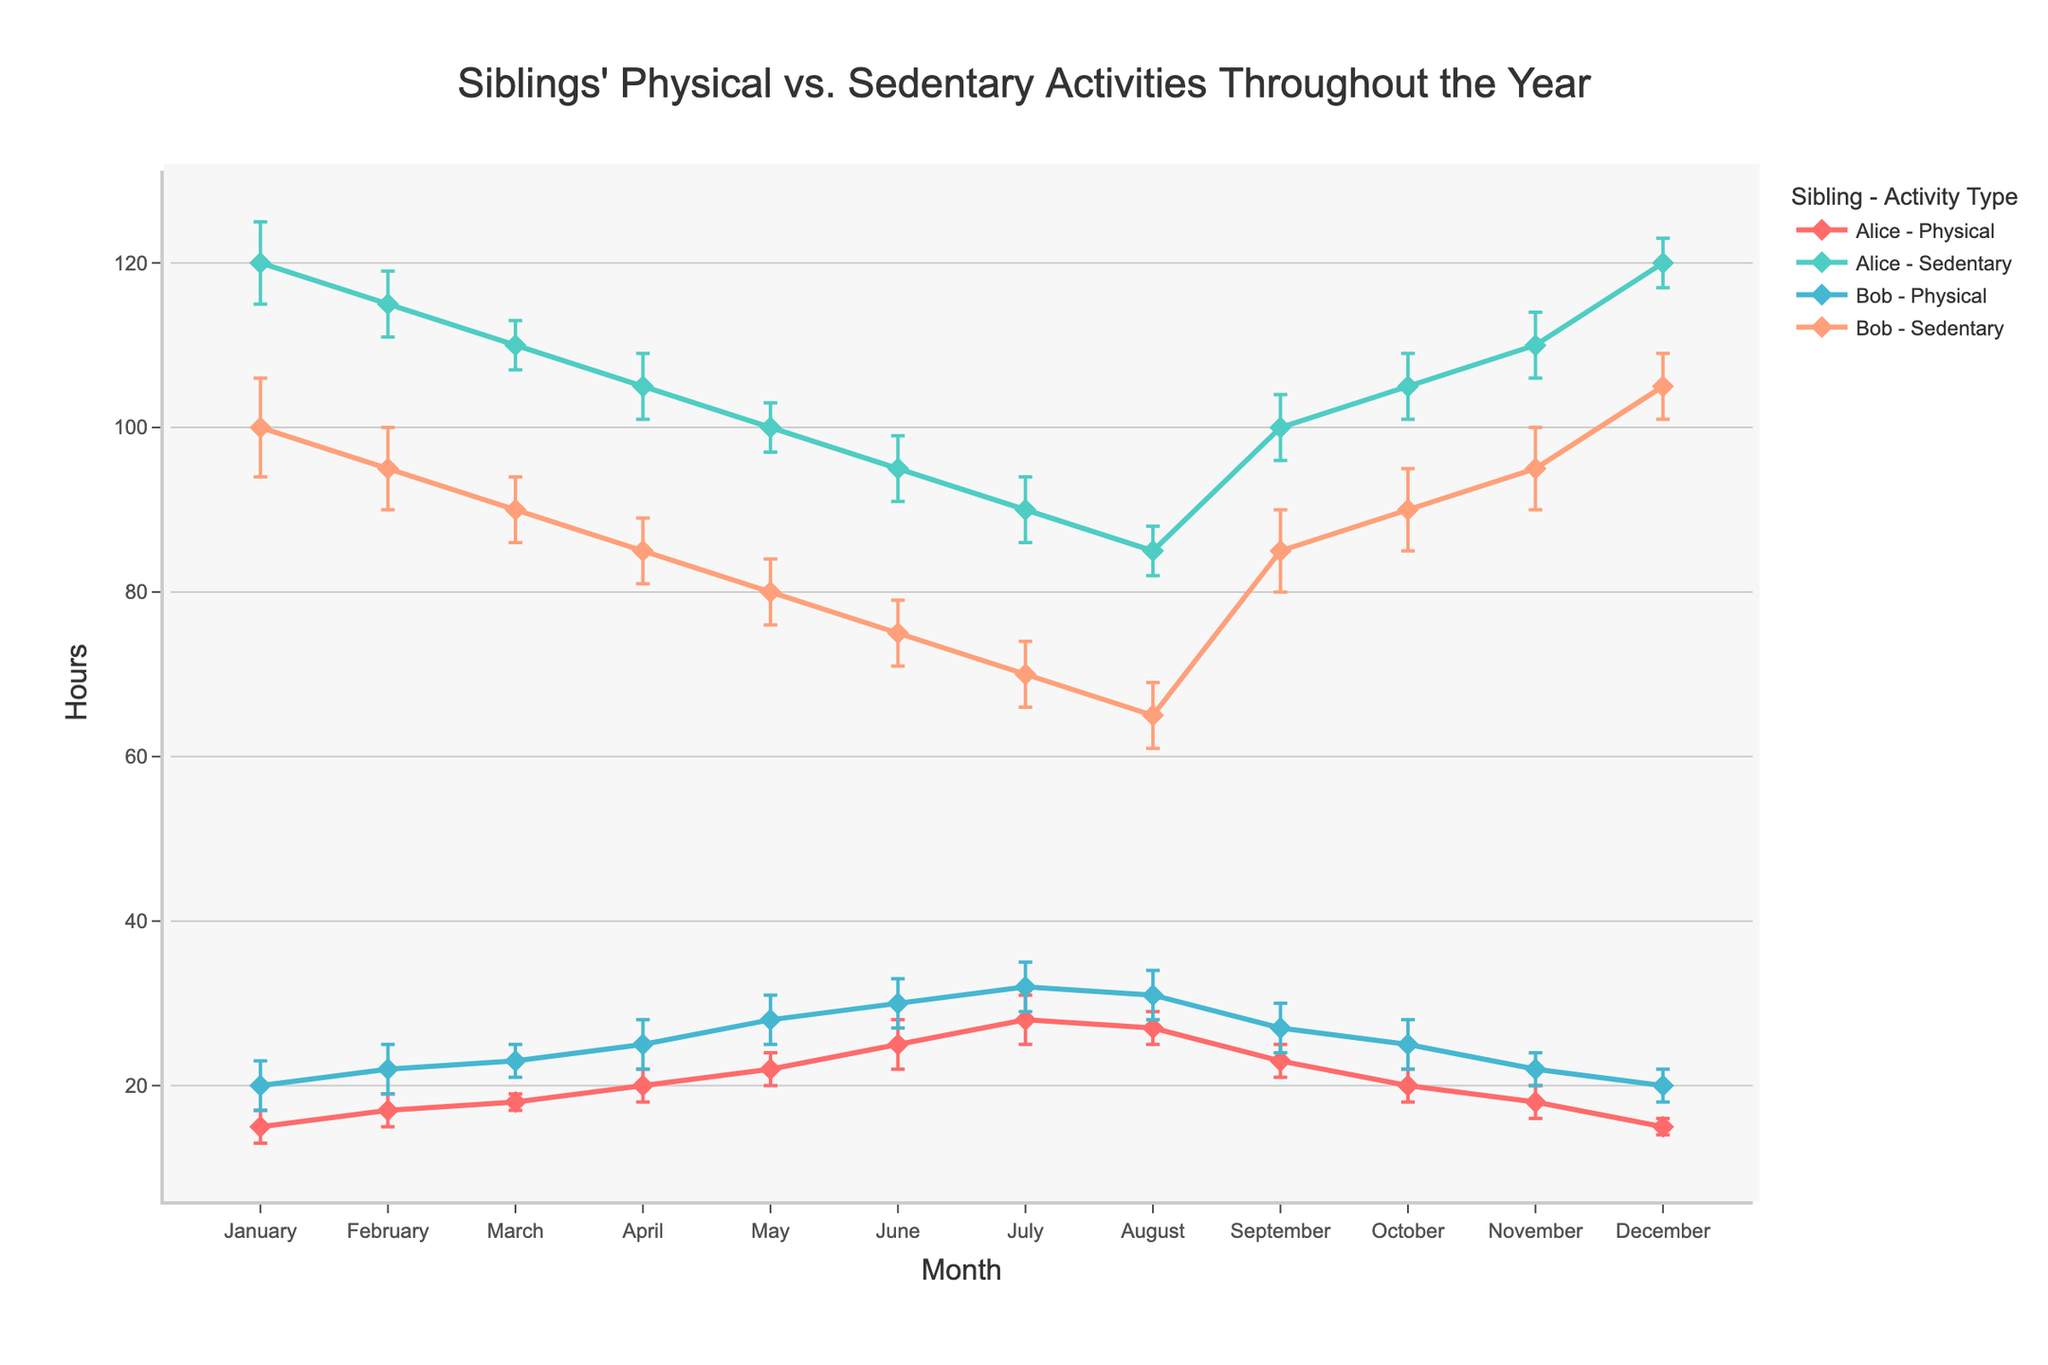what is the title of the plot? The title of the plot is located at the top center of the figure. It usually provides a brief description of what the figure represents. In this case, the title is "Siblings' Physical vs. Sedentary Activities Throughout the Year."
Answer: Siblings' Physical vs. Sedentary Activities Throughout the Year How many total hours does Alice spend on physical activities in the summer months (June, July, August)? To find the total hours, we need to sum Alice's hours for physical activities in June, July, and August: June (25) + July (28) + August (27).
Answer: 80 In which month does Bob spend the most time on physical activities? By examining Bob's physical activities line, we can observe that he spends the most time on physical activities in July, where he spends 32 hours.
Answer: July How does Alice's sedentary time change from January to December? Alice's sedentary hours in January are 120, and in December, it is also 120. By following the line for Alice's sedentary activities throughout the year, we can see that her sedentary time decreases and increases but ends the year at the same point it started.
Answer: It remains the same What is the error range for Alice's physical activity hours in May? The error range is given by the standard deviation, which represents the degree of variation. In May, Alice's physical activity hours are 22, with a standard deviation of 2. Therefore, the range is from 20 to 24 hours.
Answer: 20 to 24 hours Which sibling spent more hours on physical activities in March, and by how much? In March, Alice spent 18 hours on physical activities, and Bob spent 23 hours. The difference between their hours is 23 - 18 = 5 hours.
Answer: Bob by 5 hours Compare the sedentary activity trends for Alice and Bob from March to June. From March to June, Alice's sedentary hours steadily decrease from 110 to 95. In comparison, Bob's sedentary hours also decrease but at a slightly faster rate, from 90 down to 75. Both siblings show a decreasing trend in their sedentary activities during this period.
Answer: Both show a decreasing trend, Alice from 110 to 95, Bob from 90 to 75 Identify the month where the error bar for any activity is the largest and specify the activity and sibling. By examining all the error bars, the largest error bar is for Bob's sedentary time in January, where the standard deviation is 6. This is the highest value compared to any other month and activity.
Answer: January, Bob, Sedentary How do Bob's physical activity hours in December compare to his physical activity hours in February? Bob's physical activity hours in December are 20, while in February, they are 22. We compare the two values and find that Bob spends 2 hours fewer on physical activities in December compared to February.
Answer: 2 hours less 